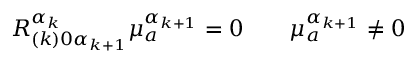<formula> <loc_0><loc_0><loc_500><loc_500>R _ { ( k ) 0 \alpha _ { k + 1 } } ^ { \alpha _ { k } } \mu _ { a } ^ { \alpha _ { k + 1 } } = 0 \quad \mu _ { a } ^ { \alpha _ { k + 1 } } \neq 0</formula> 